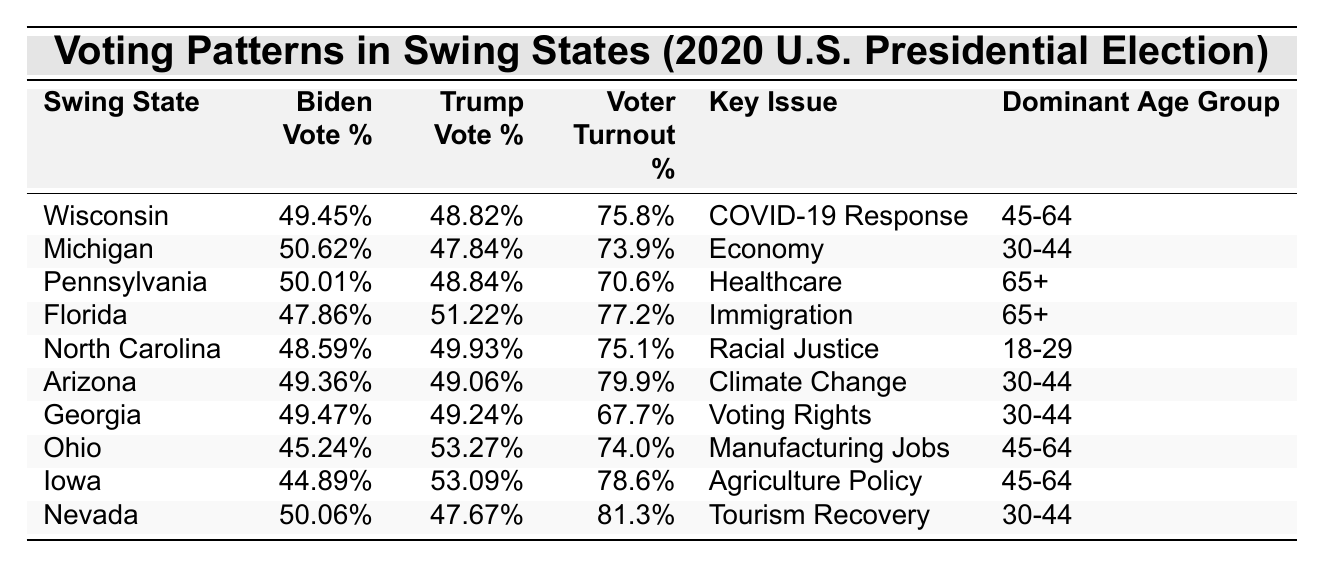What is the voter turnout percentage in Nevada? The table lists the voter turnout percentage for Nevada as 81.3%, which is explicitly stated under the "Voter Turnout %" column.
Answer: 81.3% Which swing state had the highest percentage of Trump votes? By comparing the "Trump Vote %" for each state in the table, it's evident that Ohio has the highest Trump vote percentage of 53.27%.
Answer: Ohio What is the percentage difference between Biden's and Trump's votes in Michigan? In Michigan, Biden received 50.62% of the votes and Trump received 47.84%. The difference is calculated as 50.62 - 47.84 = 2.78%.
Answer: 2.78% Is Florida's dominant age group 18-29? The table shows that the dominant age group in Florida is 65+, which does not match the specified age group of 18-29. Thus, the statement is false.
Answer: No Which state had the lowest Biden vote percentage? By examining the "Biden Vote %" column in the table, Iowa has the lowest percentage at 44.89%.
Answer: Iowa What is the average voter turnout across all listed swing states? The voter turnout percentages are: 75.8, 73.9, 70.6, 77.2, 75.1, 79.9, 67.7, 74.0, 78.6, and 81.3. Summing these gives 759.1, and dividing by 10 (the number of states) results in an average of 75.91%.
Answer: 75.91% Which key issue was prioritized by voters in Wisconsin? From the table, the key issue in Wisconsin is 'COVID-19 Response', as indicated in the corresponding row.
Answer: COVID-19 Response How many swing states had a voter turnout percentage above 78%? The states with voter turnouts above 78% are Nevada (81.3%), Arizona (79.9%), and Iowa (78.6%). Thus, there are three such states.
Answer: 3 Did the majority of voters in North Carolina favor Biden? The table states that Biden received 48.59% of the votes in North Carolina, which is less than Trump's 49.93%, meaning the majority did not favor Biden.
Answer: No Which swing state had the lowest voter turnout, and what was its percentage? Pennsylvania has a voter turnout of 70.6%, which is the lowest among the listed states.
Answer: Pennsylvania, 70.6% 